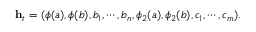<formula> <loc_0><loc_0><loc_500><loc_500>\begin{array} { r } { h _ { t } = ( \phi ( a ) , \phi ( b ) , b _ { 1 } , \cdots , b _ { n } , \phi _ { 2 } ( a ) , \phi _ { 2 } ( b ) , c _ { 1 } , \cdots , c _ { m } ) . } \end{array}</formula> 